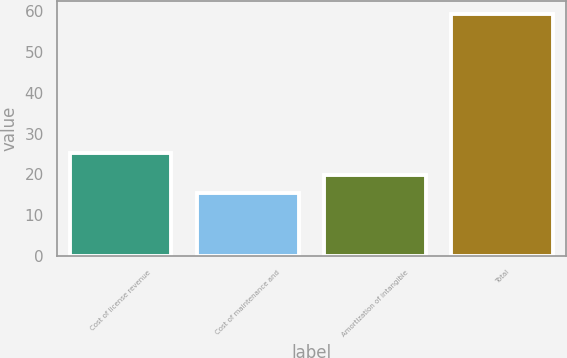Convert chart. <chart><loc_0><loc_0><loc_500><loc_500><bar_chart><fcel>Cost of license revenue<fcel>Cost of maintenance and<fcel>Amortization of intangible<fcel>Total<nl><fcel>25.3<fcel>15.4<fcel>19.8<fcel>59.4<nl></chart> 